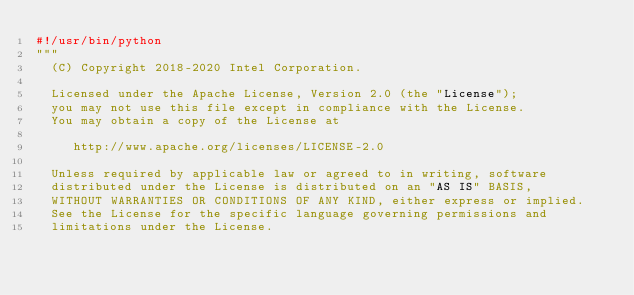Convert code to text. <code><loc_0><loc_0><loc_500><loc_500><_Python_>#!/usr/bin/python
"""
  (C) Copyright 2018-2020 Intel Corporation.

  Licensed under the Apache License, Version 2.0 (the "License");
  you may not use this file except in compliance with the License.
  You may obtain a copy of the License at

     http://www.apache.org/licenses/LICENSE-2.0

  Unless required by applicable law or agreed to in writing, software
  distributed under the License is distributed on an "AS IS" BASIS,
  WITHOUT WARRANTIES OR CONDITIONS OF ANY KIND, either express or implied.
  See the License for the specific language governing permissions and
  limitations under the License.
</code> 